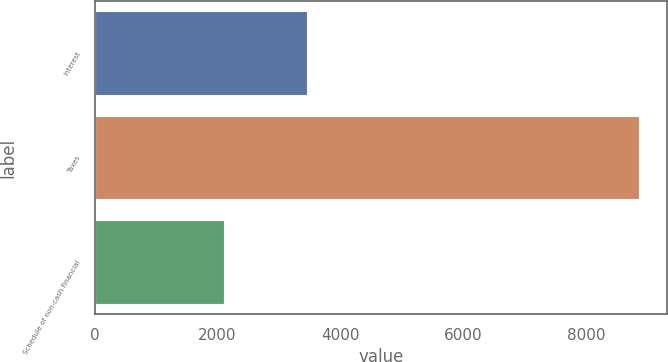Convert chart to OTSL. <chart><loc_0><loc_0><loc_500><loc_500><bar_chart><fcel>Interest<fcel>Taxes<fcel>Schedule of non-cash financial<nl><fcel>3458<fcel>8871<fcel>2101<nl></chart> 